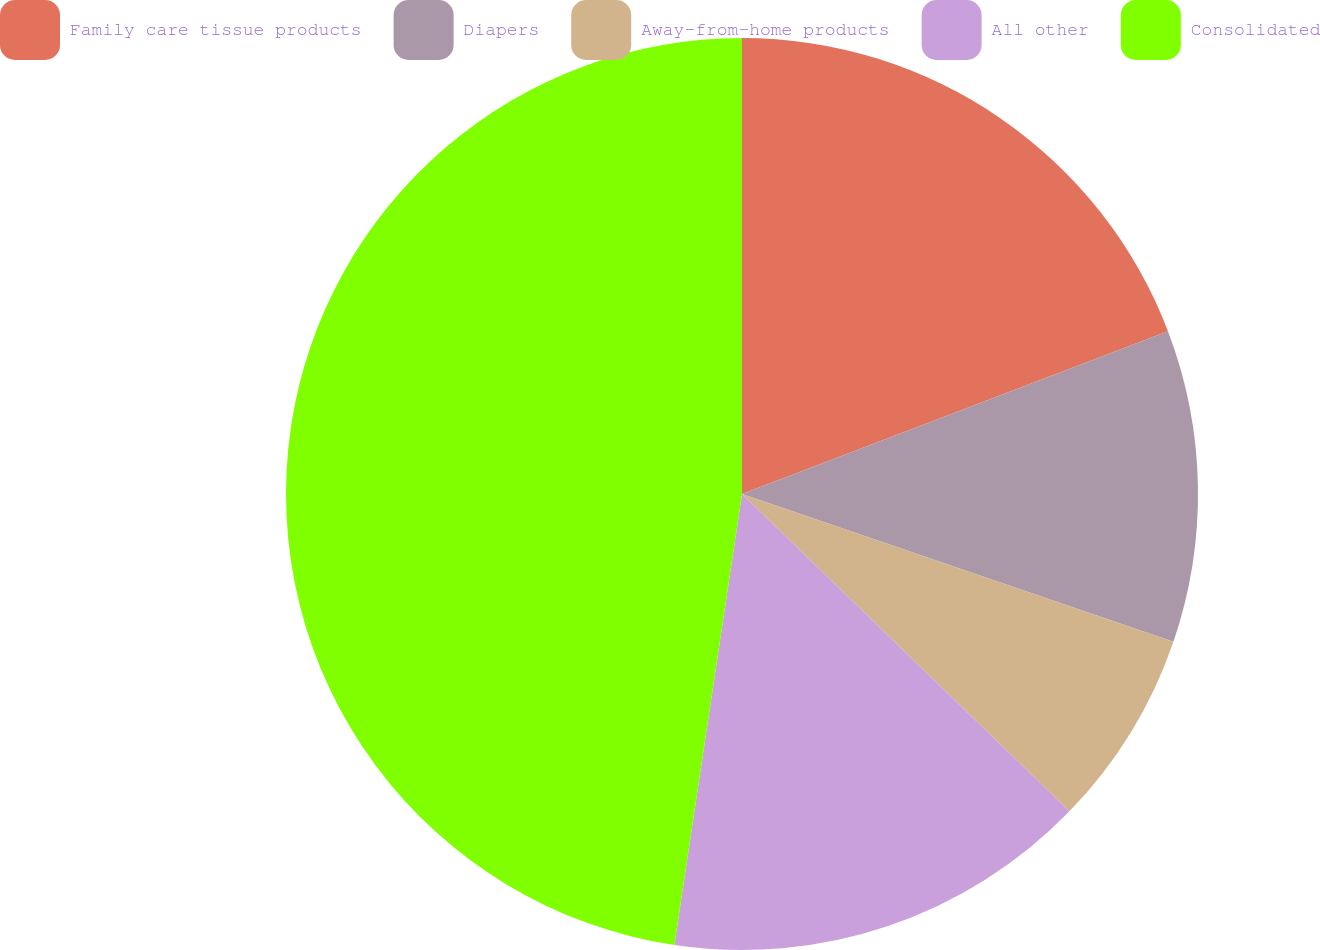Convert chart. <chart><loc_0><loc_0><loc_500><loc_500><pie_chart><fcel>Family care tissue products<fcel>Diapers<fcel>Away-from-home products<fcel>All other<fcel>Consolidated<nl><fcel>19.19%<fcel>11.06%<fcel>7.0%<fcel>15.12%<fcel>47.63%<nl></chart> 